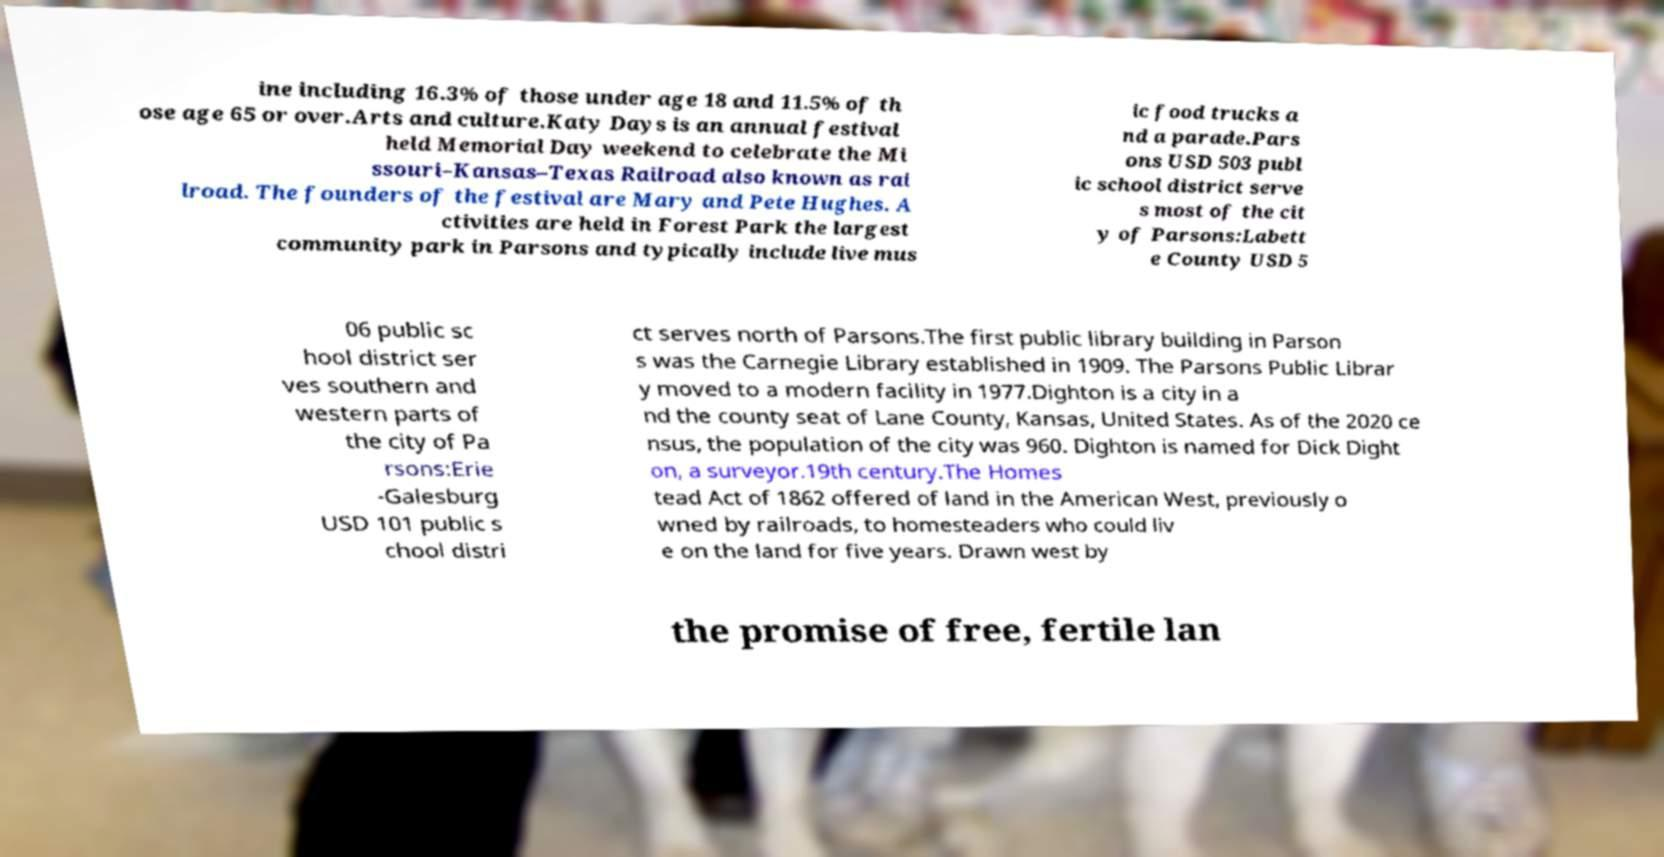Please read and relay the text visible in this image. What does it say? ine including 16.3% of those under age 18 and 11.5% of th ose age 65 or over.Arts and culture.Katy Days is an annual festival held Memorial Day weekend to celebrate the Mi ssouri–Kansas–Texas Railroad also known as rai lroad. The founders of the festival are Mary and Pete Hughes. A ctivities are held in Forest Park the largest community park in Parsons and typically include live mus ic food trucks a nd a parade.Pars ons USD 503 publ ic school district serve s most of the cit y of Parsons:Labett e County USD 5 06 public sc hool district ser ves southern and western parts of the city of Pa rsons:Erie -Galesburg USD 101 public s chool distri ct serves north of Parsons.The first public library building in Parson s was the Carnegie Library established in 1909. The Parsons Public Librar y moved to a modern facility in 1977.Dighton is a city in a nd the county seat of Lane County, Kansas, United States. As of the 2020 ce nsus, the population of the city was 960. Dighton is named for Dick Dight on, a surveyor.19th century.The Homes tead Act of 1862 offered of land in the American West, previously o wned by railroads, to homesteaders who could liv e on the land for five years. Drawn west by the promise of free, fertile lan 